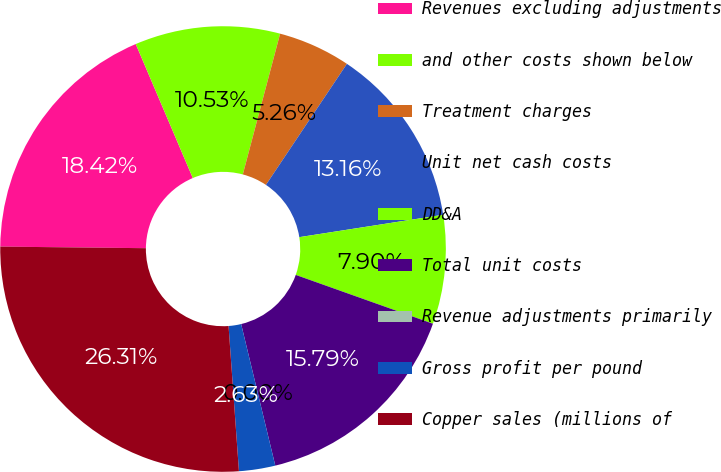Convert chart to OTSL. <chart><loc_0><loc_0><loc_500><loc_500><pie_chart><fcel>Revenues excluding adjustments<fcel>and other costs shown below<fcel>Treatment charges<fcel>Unit net cash costs<fcel>DD&A<fcel>Total unit costs<fcel>Revenue adjustments primarily<fcel>Gross profit per pound<fcel>Copper sales (millions of<nl><fcel>18.42%<fcel>10.53%<fcel>5.26%<fcel>13.16%<fcel>7.9%<fcel>15.79%<fcel>0.0%<fcel>2.63%<fcel>26.31%<nl></chart> 